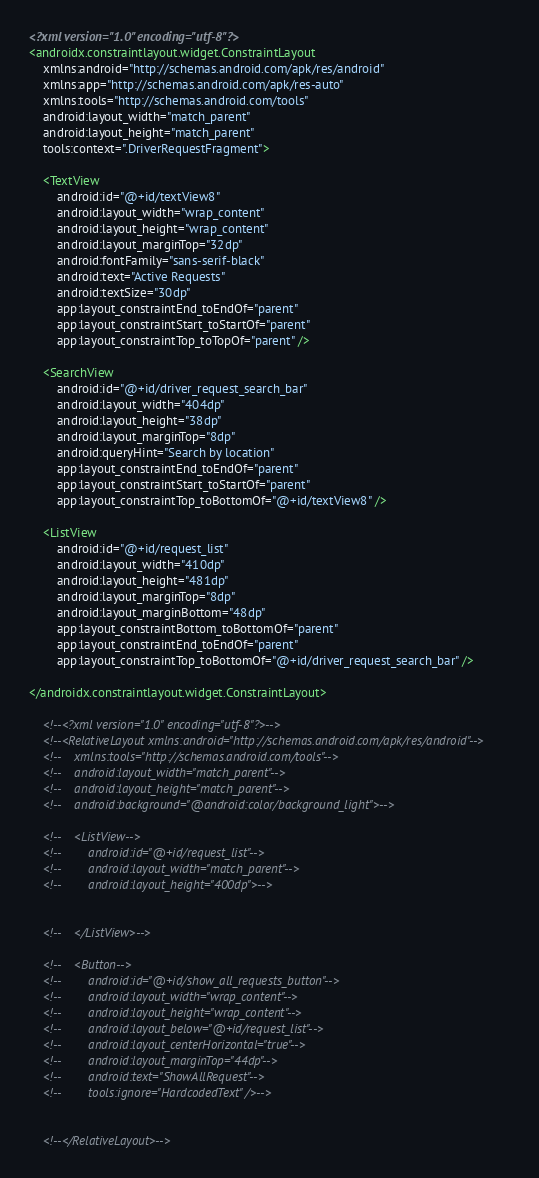Convert code to text. <code><loc_0><loc_0><loc_500><loc_500><_XML_><?xml version="1.0" encoding="utf-8"?>
<androidx.constraintlayout.widget.ConstraintLayout
    xmlns:android="http://schemas.android.com/apk/res/android"
    xmlns:app="http://schemas.android.com/apk/res-auto"
    xmlns:tools="http://schemas.android.com/tools"
    android:layout_width="match_parent"
    android:layout_height="match_parent"
    tools:context=".DriverRequestFragment">

    <TextView
        android:id="@+id/textView8"
        android:layout_width="wrap_content"
        android:layout_height="wrap_content"
        android:layout_marginTop="32dp"
        android:fontFamily="sans-serif-black"
        android:text="Active Requests"
        android:textSize="30dp"
        app:layout_constraintEnd_toEndOf="parent"
        app:layout_constraintStart_toStartOf="parent"
        app:layout_constraintTop_toTopOf="parent" />

    <SearchView
        android:id="@+id/driver_request_search_bar"
        android:layout_width="404dp"
        android:layout_height="38dp"
        android:layout_marginTop="8dp"
        android:queryHint="Search by location"
        app:layout_constraintEnd_toEndOf="parent"
        app:layout_constraintStart_toStartOf="parent"
        app:layout_constraintTop_toBottomOf="@+id/textView8" />

    <ListView
        android:id="@+id/request_list"
        android:layout_width="410dp"
        android:layout_height="481dp"
        android:layout_marginTop="8dp"
        android:layout_marginBottom="48dp"
        app:layout_constraintBottom_toBottomOf="parent"
        app:layout_constraintEnd_toEndOf="parent"
        app:layout_constraintTop_toBottomOf="@+id/driver_request_search_bar" />

</androidx.constraintlayout.widget.ConstraintLayout>

    <!--<?xml version="1.0" encoding="utf-8"?>-->
    <!--<RelativeLayout xmlns:android="http://schemas.android.com/apk/res/android"-->
    <!--    xmlns:tools="http://schemas.android.com/tools"-->
    <!--    android:layout_width="match_parent"-->
    <!--    android:layout_height="match_parent"-->
    <!--    android:background="@android:color/background_light">-->

    <!--    <ListView-->
    <!--        android:id="@+id/request_list"-->
    <!--        android:layout_width="match_parent"-->
    <!--        android:layout_height="400dp">-->


    <!--    </ListView>-->

    <!--    <Button-->
    <!--        android:id="@+id/show_all_requests_button"-->
    <!--        android:layout_width="wrap_content"-->
    <!--        android:layout_height="wrap_content"-->
    <!--        android:layout_below="@+id/request_list"-->
    <!--        android:layout_centerHorizontal="true"-->
    <!--        android:layout_marginTop="44dp"-->
    <!--        android:text="ShowAllRequest"-->
    <!--        tools:ignore="HardcodedText" />-->


    <!--</RelativeLayout>-->

</code> 